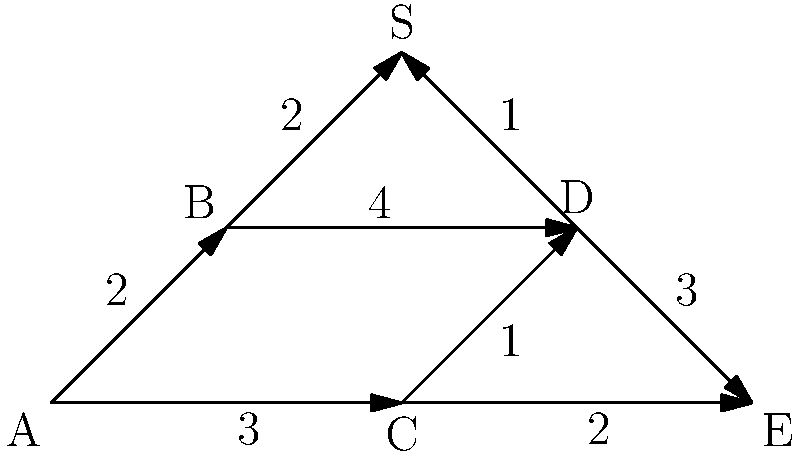Given the graph representing evacuation routes from different city zones (A, B, C, D, E) to a safe zone (S), what is the minimum time required to evacuate all zones, assuming evacuations can occur simultaneously and the time for each route is represented by the edge weights? To find the minimum time required to evacuate all zones, we need to determine the longest path from any zone to the safe zone S. This is because evacuations can occur simultaneously, so the total evacuation time will be determined by the zone that takes the longest to evacuate.

Let's analyze the paths from each zone to S:

1. From A:
   A → B → S: 2 + 2 = 4
   A → B → D → S: 2 + 4 + 1 = 7
   A → C → D → S: 3 + 1 + 1 = 5

2. From B:
   B → S: 2
   B → D → S: 4 + 1 = 5

3. From C:
   C → D → S: 1 + 1 = 2

4. From D:
   D → S: 1

5. From E:
   E → D → S: 3 + 1 = 4

The longest path is from A to S via B and D, which takes 7 time units. This represents the minimum time required to evacuate all zones, as all other zones can be evacuated within this timeframe.
Answer: 7 time units 